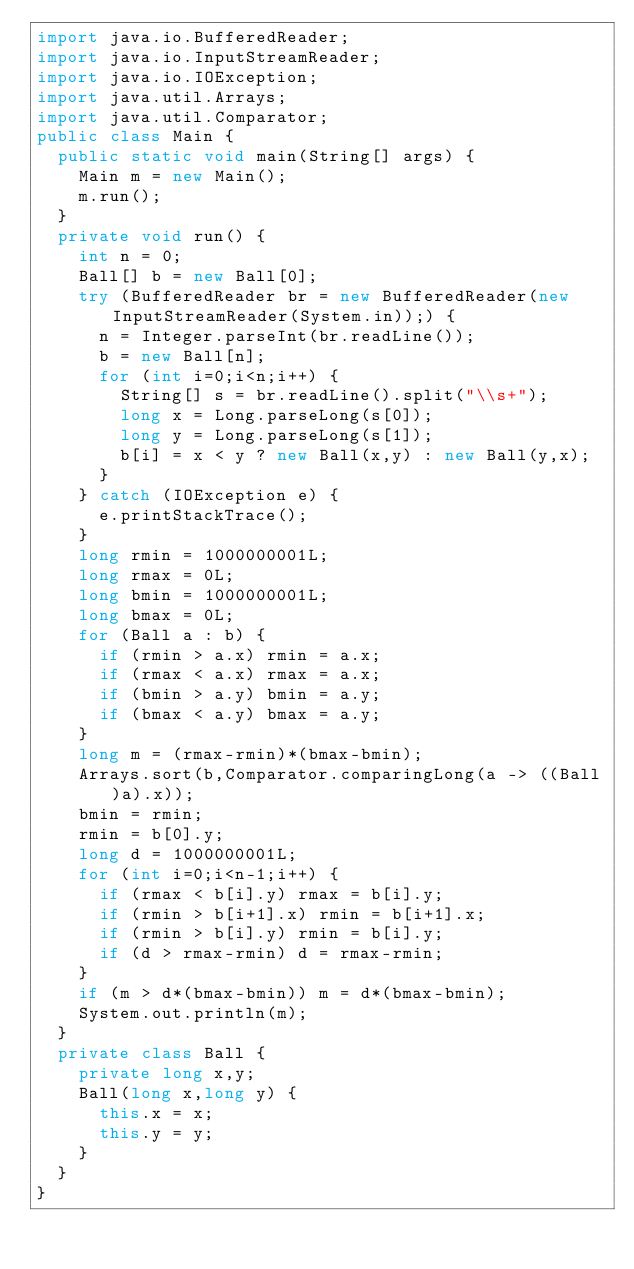Convert code to text. <code><loc_0><loc_0><loc_500><loc_500><_Java_>import java.io.BufferedReader;
import java.io.InputStreamReader;
import java.io.IOException;
import java.util.Arrays;
import java.util.Comparator;
public class Main {
  public static void main(String[] args) {
    Main m = new Main();
    m.run();
  }
  private void run() {
    int n = 0;
    Ball[] b = new Ball[0];
    try (BufferedReader br = new BufferedReader(new InputStreamReader(System.in));) {
      n = Integer.parseInt(br.readLine());
      b = new Ball[n];
      for (int i=0;i<n;i++) {
        String[] s = br.readLine().split("\\s+");
        long x = Long.parseLong(s[0]);
        long y = Long.parseLong(s[1]);
        b[i] = x < y ? new Ball(x,y) : new Ball(y,x);
      }
    } catch (IOException e) {
      e.printStackTrace();
    }
    long rmin = 1000000001L;
    long rmax = 0L;
    long bmin = 1000000001L;
    long bmax = 0L;
    for (Ball a : b) {
      if (rmin > a.x) rmin = a.x;
      if (rmax < a.x) rmax = a.x;
      if (bmin > a.y) bmin = a.y;
      if (bmax < a.y) bmax = a.y;
    }
    long m = (rmax-rmin)*(bmax-bmin);
    Arrays.sort(b,Comparator.comparingLong(a -> ((Ball)a).x));
    bmin = rmin;
    rmin = b[0].y;
    long d = 1000000001L;
    for (int i=0;i<n-1;i++) {
      if (rmax < b[i].y) rmax = b[i].y;
      if (rmin > b[i+1].x) rmin = b[i+1].x;
      if (rmin > b[i].y) rmin = b[i].y;
      if (d > rmax-rmin) d = rmax-rmin;
    }
    if (m > d*(bmax-bmin)) m = d*(bmax-bmin);
    System.out.println(m);
  }
  private class Ball {
    private long x,y;
    Ball(long x,long y) {
      this.x = x;
      this.y = y;
    }
  }
}</code> 